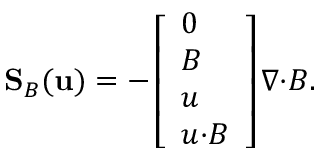<formula> <loc_0><loc_0><loc_500><loc_500>S _ { B } ( u ) = - \left [ \begin{array} { l } { 0 } \\ { B } \\ { u } \\ { u { \cdot } B } \end{array} \right ] \nabla { \cdot } B .</formula> 